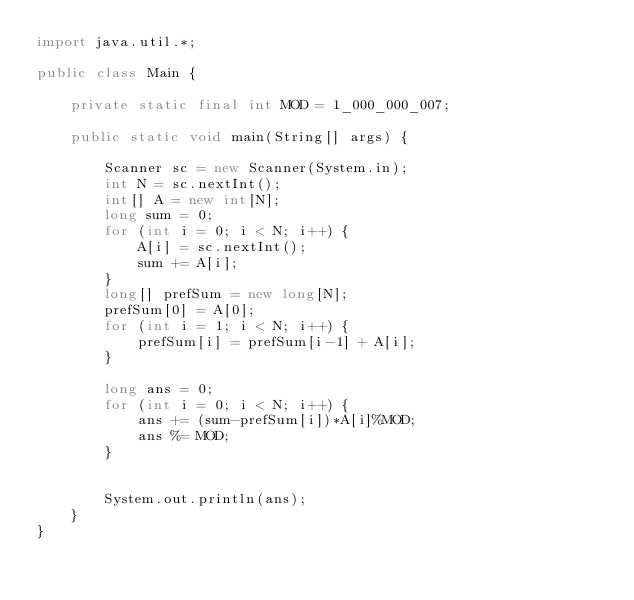Convert code to text. <code><loc_0><loc_0><loc_500><loc_500><_Java_>import java.util.*;

public class Main {

    private static final int MOD = 1_000_000_007;

    public static void main(String[] args) {

        Scanner sc = new Scanner(System.in);
        int N = sc.nextInt();
        int[] A = new int[N];
        long sum = 0;
        for (int i = 0; i < N; i++) {
            A[i] = sc.nextInt();
            sum += A[i];
        }
        long[] prefSum = new long[N];
        prefSum[0] = A[0];
        for (int i = 1; i < N; i++) {
            prefSum[i] = prefSum[i-1] + A[i];
        }

        long ans = 0;
        for (int i = 0; i < N; i++) {
            ans += (sum-prefSum[i])*A[i]%MOD;
            ans %= MOD;
        }


        System.out.println(ans);
    }
}
</code> 